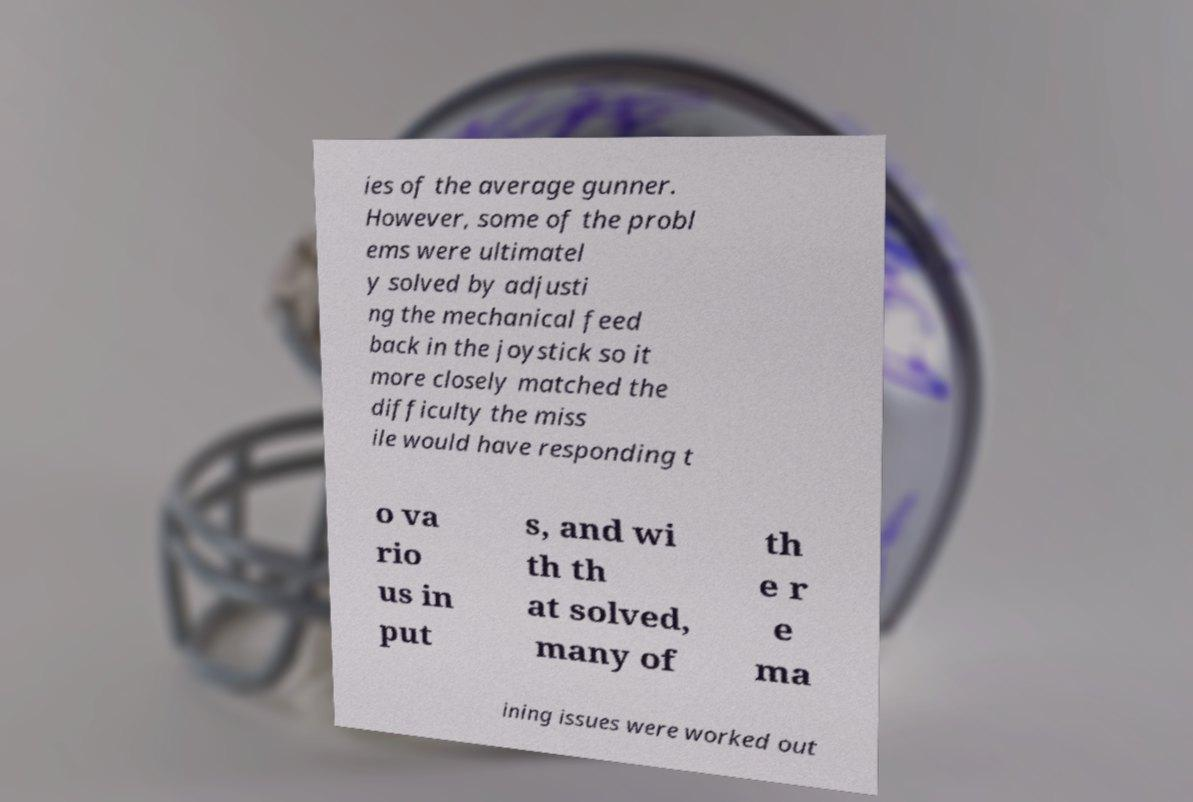Please identify and transcribe the text found in this image. ies of the average gunner. However, some of the probl ems were ultimatel y solved by adjusti ng the mechanical feed back in the joystick so it more closely matched the difficulty the miss ile would have responding t o va rio us in put s, and wi th th at solved, many of th e r e ma ining issues were worked out 